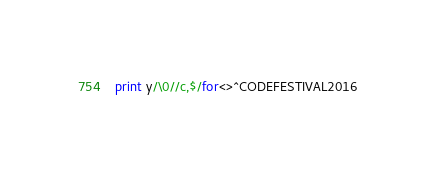Convert code to text. <code><loc_0><loc_0><loc_500><loc_500><_Perl_>print y/\0//c,$/for<>^CODEFESTIVAL2016</code> 